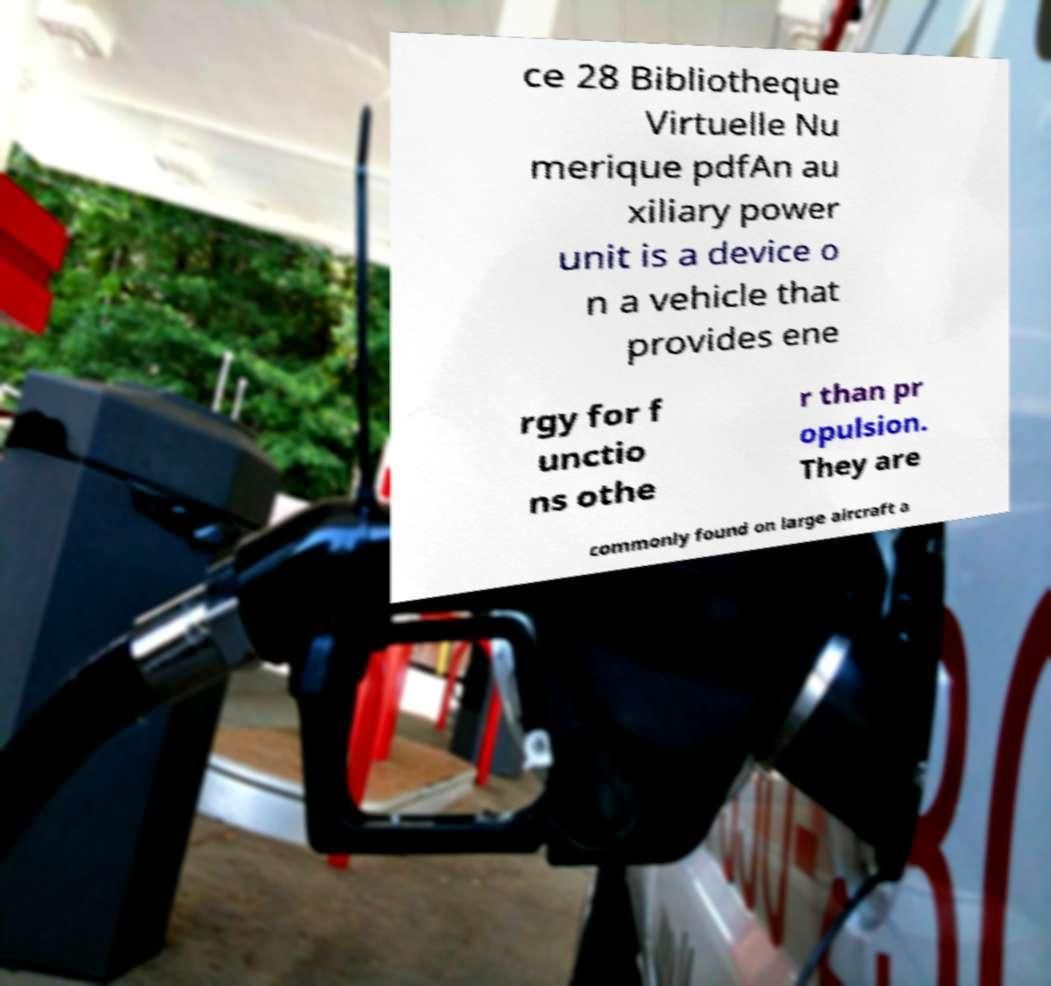Can you accurately transcribe the text from the provided image for me? ce 28 Bibliotheque Virtuelle Nu merique pdfAn au xiliary power unit is a device o n a vehicle that provides ene rgy for f unctio ns othe r than pr opulsion. They are commonly found on large aircraft a 